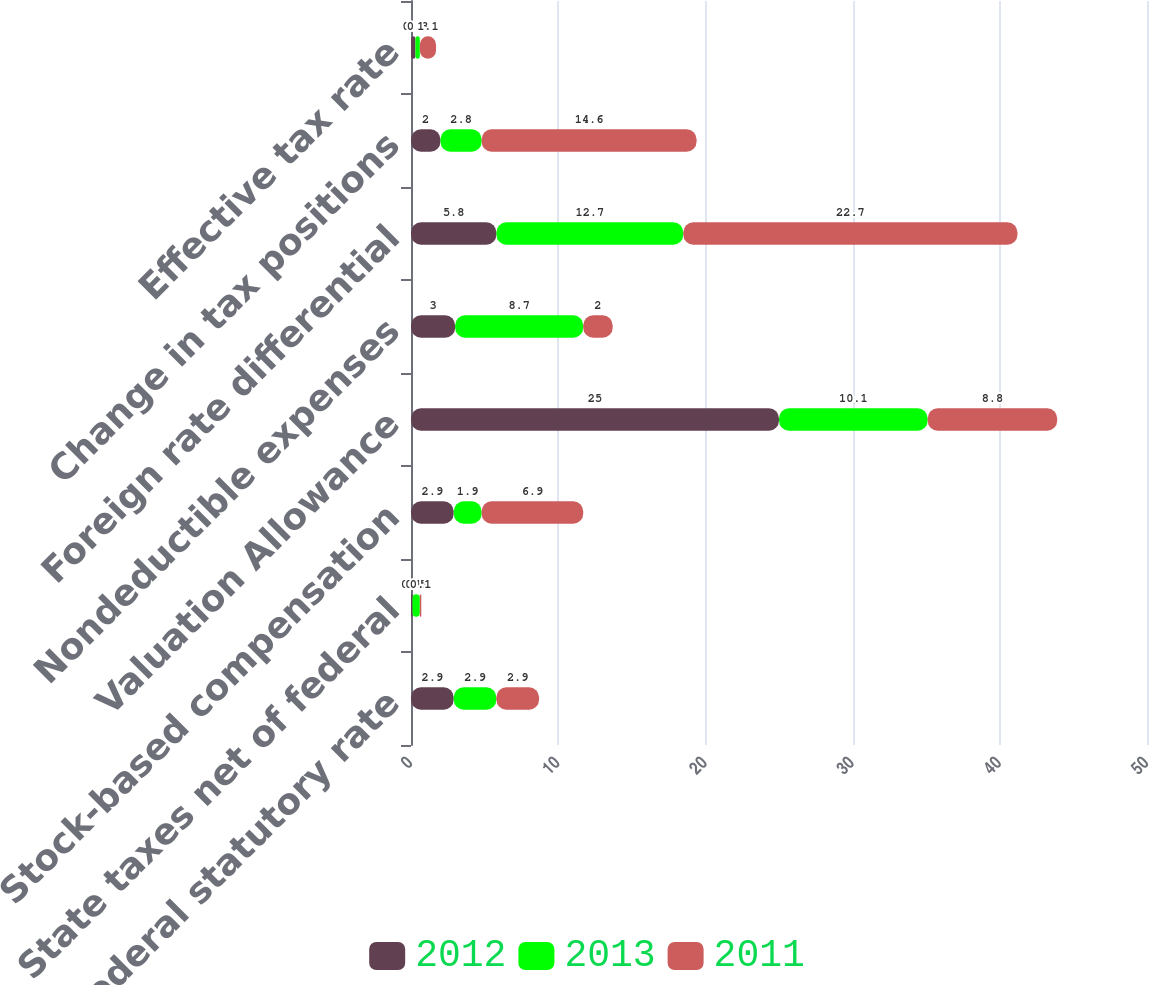<chart> <loc_0><loc_0><loc_500><loc_500><stacked_bar_chart><ecel><fcel>Tax at federal statutory rate<fcel>State taxes net of federal<fcel>Stock-based compensation<fcel>Valuation Allowance<fcel>Nondeductible expenses<fcel>Foreign rate differential<fcel>Change in tax positions<fcel>Effective tax rate<nl><fcel>2012<fcel>2.9<fcel>0.1<fcel>2.9<fcel>25<fcel>3<fcel>5.8<fcel>2<fcel>0.3<nl><fcel>2013<fcel>2.9<fcel>0.5<fcel>1.9<fcel>10.1<fcel>8.7<fcel>12.7<fcel>2.8<fcel>0.3<nl><fcel>2011<fcel>2.9<fcel>0.1<fcel>6.9<fcel>8.8<fcel>2<fcel>22.7<fcel>14.6<fcel>1.1<nl></chart> 